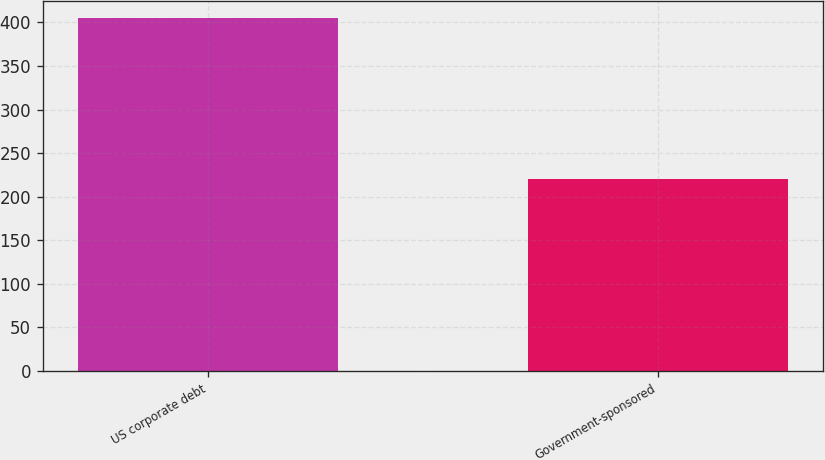Convert chart. <chart><loc_0><loc_0><loc_500><loc_500><bar_chart><fcel>US corporate debt<fcel>Government-sponsored<nl><fcel>405<fcel>220<nl></chart> 